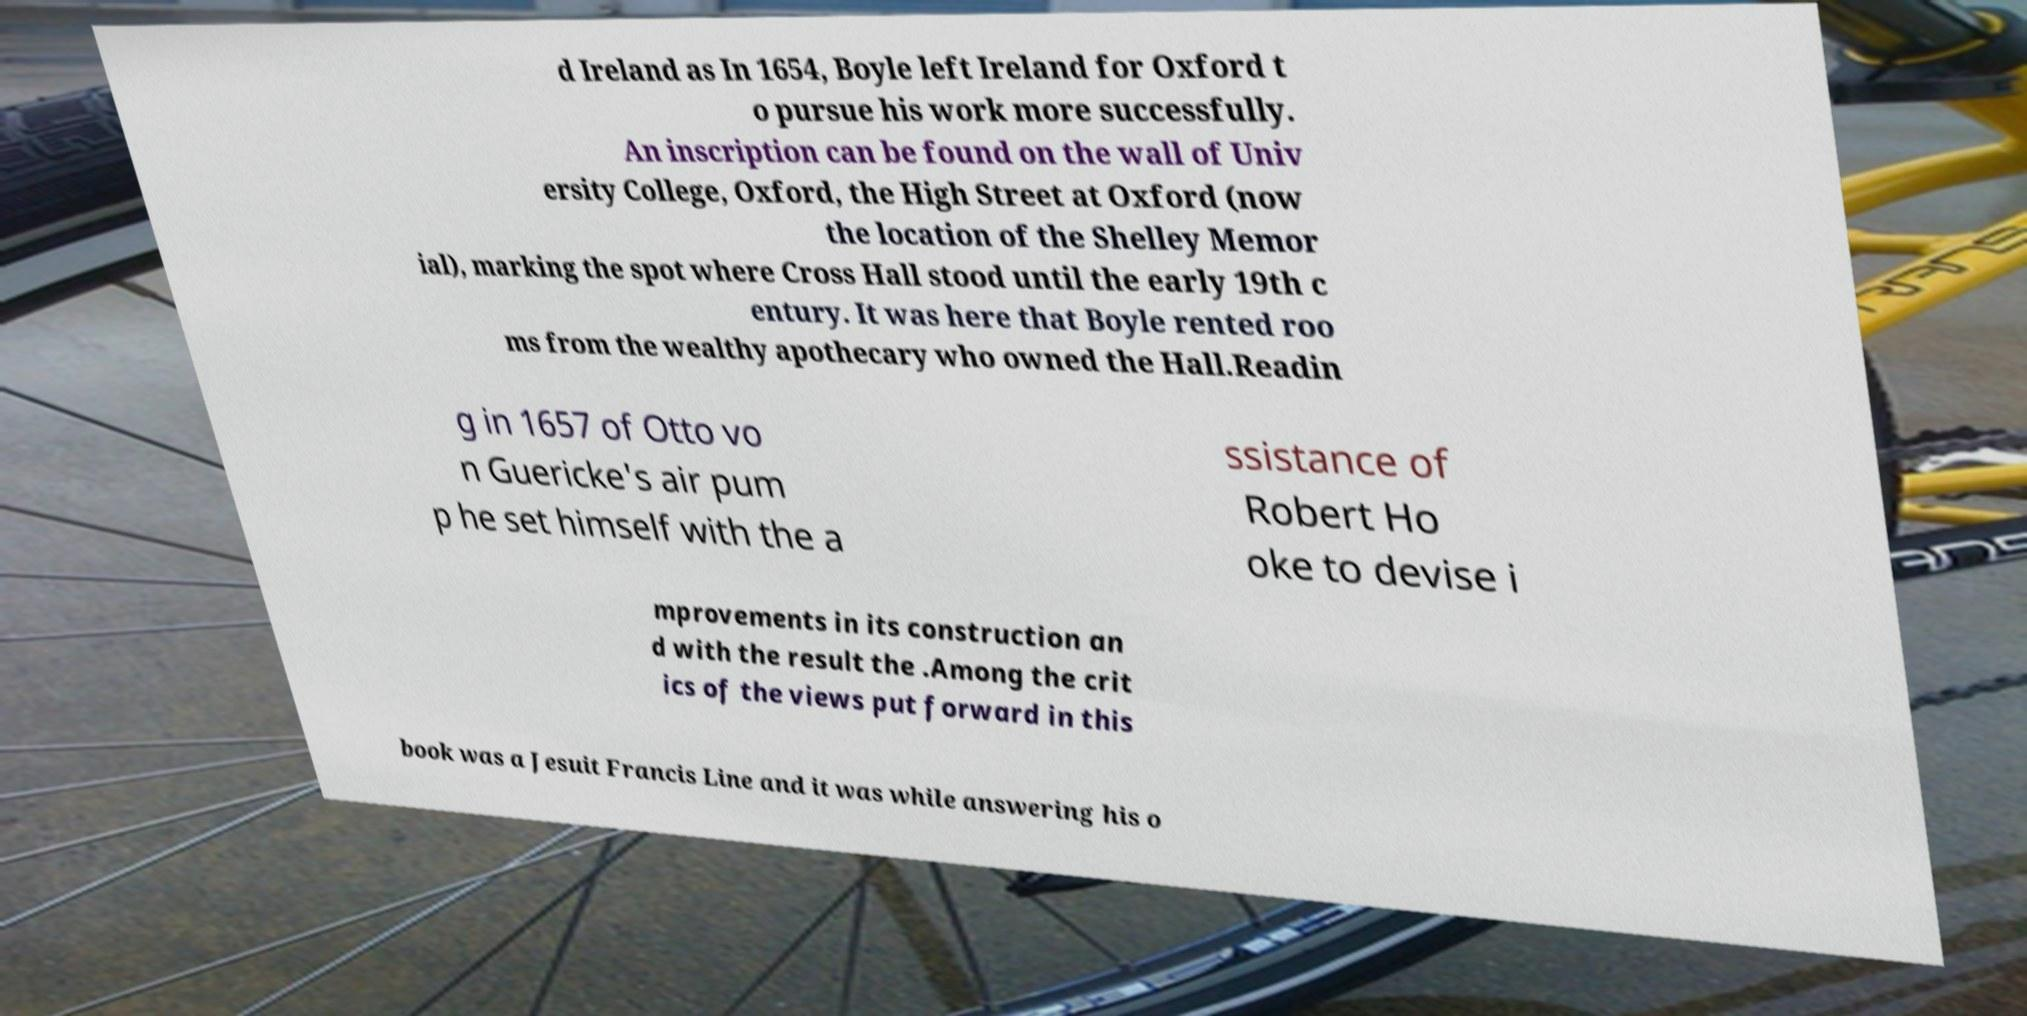Please identify and transcribe the text found in this image. d Ireland as In 1654, Boyle left Ireland for Oxford t o pursue his work more successfully. An inscription can be found on the wall of Univ ersity College, Oxford, the High Street at Oxford (now the location of the Shelley Memor ial), marking the spot where Cross Hall stood until the early 19th c entury. It was here that Boyle rented roo ms from the wealthy apothecary who owned the Hall.Readin g in 1657 of Otto vo n Guericke's air pum p he set himself with the a ssistance of Robert Ho oke to devise i mprovements in its construction an d with the result the .Among the crit ics of the views put forward in this book was a Jesuit Francis Line and it was while answering his o 